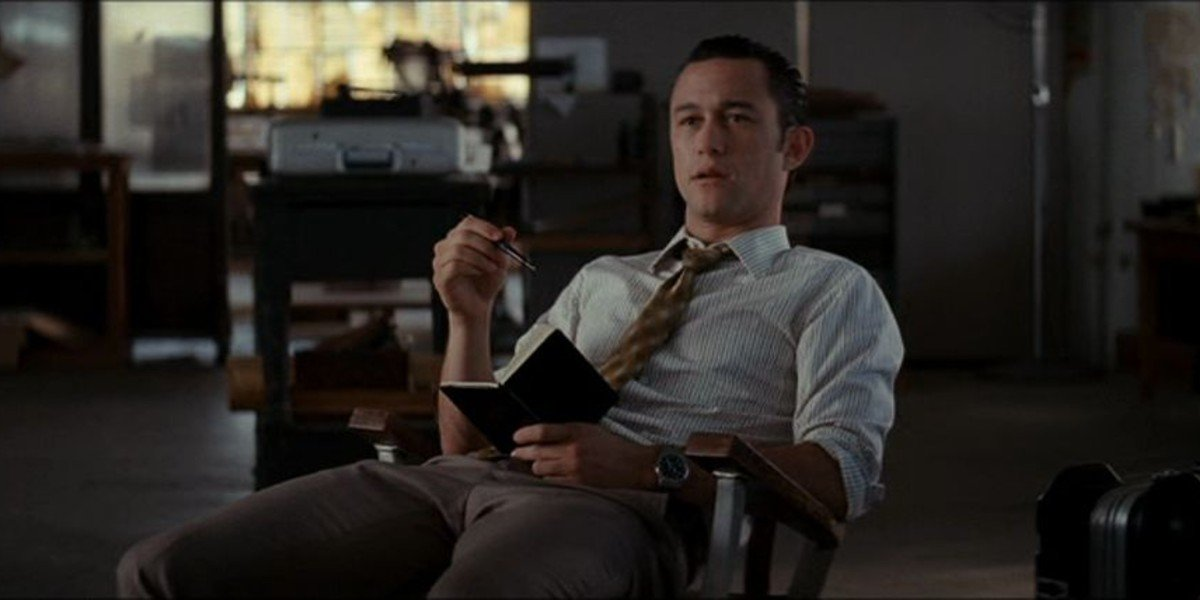Can you speculate what the man might be thinking about? Given his professional attire and the presence of a book and pen, it's possible that he is pondering over an important work-related matter. He might be thinking about a complex problem he needs to solve, reviewing notes for an upcoming presentation, or coming up with new creative ideas for a project. 